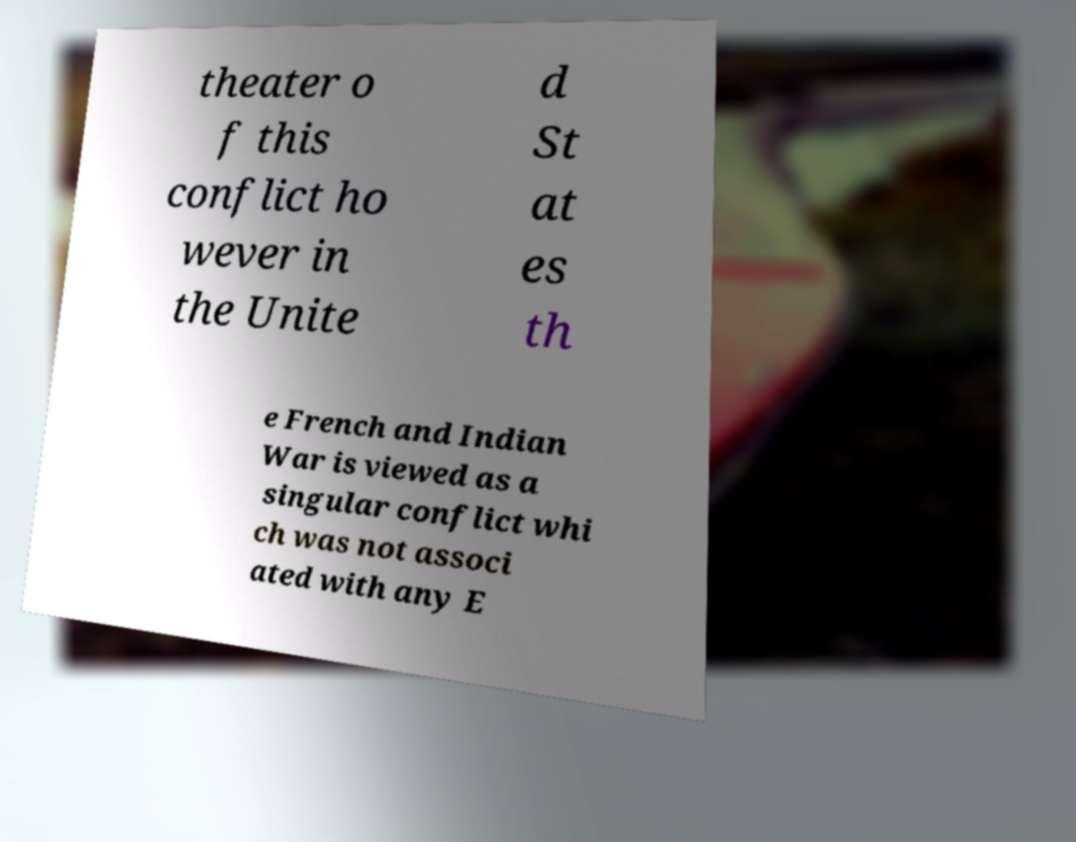Could you extract and type out the text from this image? theater o f this conflict ho wever in the Unite d St at es th e French and Indian War is viewed as a singular conflict whi ch was not associ ated with any E 